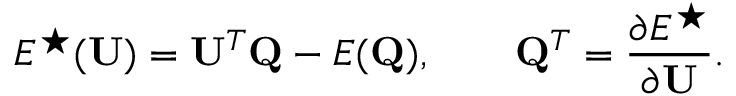<formula> <loc_0><loc_0><loc_500><loc_500>E ^ { ^ { * } } ( U ) = U ^ { T } Q - E ( Q ) , \quad Q ^ { T } = \frac { \partial E ^ { ^ { * } } } { \partial U } .</formula> 